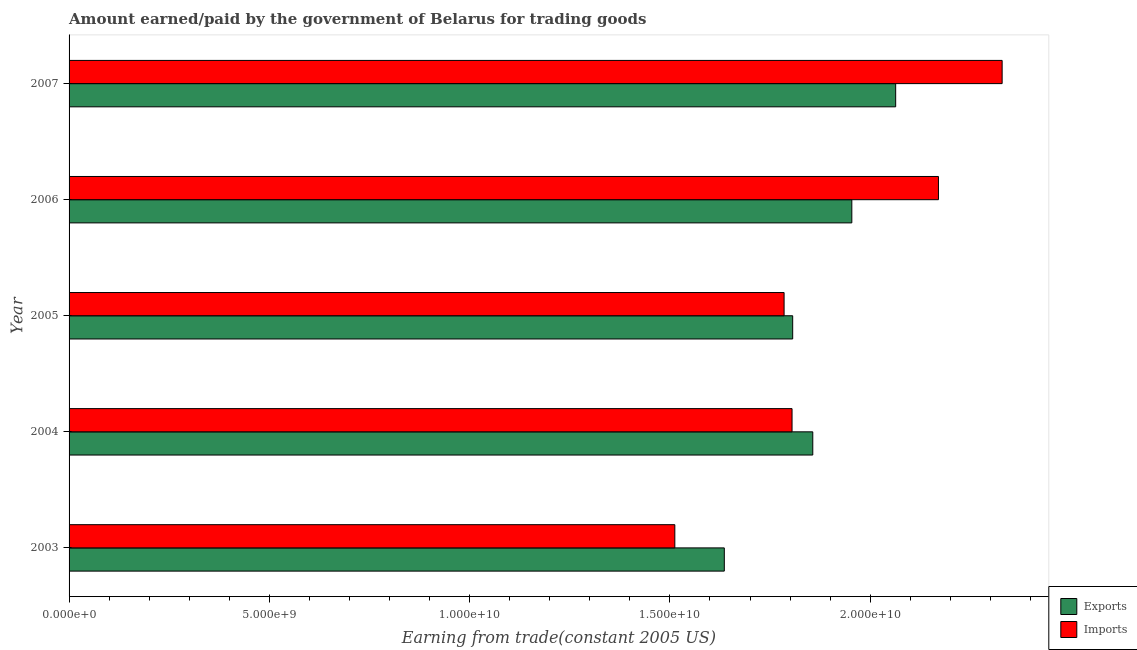How many different coloured bars are there?
Ensure brevity in your answer.  2. Are the number of bars per tick equal to the number of legend labels?
Give a very brief answer. Yes. How many bars are there on the 1st tick from the bottom?
Make the answer very short. 2. In how many cases, is the number of bars for a given year not equal to the number of legend labels?
Provide a short and direct response. 0. What is the amount paid for imports in 2004?
Keep it short and to the point. 1.80e+1. Across all years, what is the maximum amount paid for imports?
Offer a terse response. 2.33e+1. Across all years, what is the minimum amount earned from exports?
Your answer should be very brief. 1.64e+1. In which year was the amount paid for imports maximum?
Provide a short and direct response. 2007. In which year was the amount paid for imports minimum?
Your answer should be compact. 2003. What is the total amount earned from exports in the graph?
Your answer should be compact. 9.32e+1. What is the difference between the amount earned from exports in 2003 and that in 2005?
Keep it short and to the point. -1.71e+09. What is the difference between the amount paid for imports in 2007 and the amount earned from exports in 2005?
Keep it short and to the point. 5.23e+09. What is the average amount paid for imports per year?
Your answer should be very brief. 1.92e+1. In the year 2005, what is the difference between the amount earned from exports and amount paid for imports?
Provide a succinct answer. 2.15e+08. What is the ratio of the amount paid for imports in 2005 to that in 2006?
Ensure brevity in your answer.  0.82. Is the amount paid for imports in 2003 less than that in 2006?
Offer a very short reply. Yes. What is the difference between the highest and the second highest amount paid for imports?
Provide a short and direct response. 1.59e+09. What is the difference between the highest and the lowest amount earned from exports?
Offer a terse response. 4.28e+09. In how many years, is the amount paid for imports greater than the average amount paid for imports taken over all years?
Offer a very short reply. 2. Is the sum of the amount earned from exports in 2005 and 2006 greater than the maximum amount paid for imports across all years?
Keep it short and to the point. Yes. What does the 1st bar from the top in 2003 represents?
Your answer should be very brief. Imports. What does the 2nd bar from the bottom in 2003 represents?
Make the answer very short. Imports. Are all the bars in the graph horizontal?
Make the answer very short. Yes. Does the graph contain any zero values?
Your answer should be compact. No. Where does the legend appear in the graph?
Your response must be concise. Bottom right. What is the title of the graph?
Your answer should be very brief. Amount earned/paid by the government of Belarus for trading goods. What is the label or title of the X-axis?
Your response must be concise. Earning from trade(constant 2005 US). What is the label or title of the Y-axis?
Your response must be concise. Year. What is the Earning from trade(constant 2005 US) of Exports in 2003?
Make the answer very short. 1.64e+1. What is the Earning from trade(constant 2005 US) in Imports in 2003?
Provide a succinct answer. 1.51e+1. What is the Earning from trade(constant 2005 US) in Exports in 2004?
Offer a very short reply. 1.86e+1. What is the Earning from trade(constant 2005 US) in Imports in 2004?
Ensure brevity in your answer.  1.80e+1. What is the Earning from trade(constant 2005 US) in Exports in 2005?
Provide a short and direct response. 1.81e+1. What is the Earning from trade(constant 2005 US) of Imports in 2005?
Give a very brief answer. 1.79e+1. What is the Earning from trade(constant 2005 US) of Exports in 2006?
Give a very brief answer. 1.95e+1. What is the Earning from trade(constant 2005 US) in Imports in 2006?
Offer a very short reply. 2.17e+1. What is the Earning from trade(constant 2005 US) in Exports in 2007?
Offer a terse response. 2.06e+1. What is the Earning from trade(constant 2005 US) in Imports in 2007?
Offer a terse response. 2.33e+1. Across all years, what is the maximum Earning from trade(constant 2005 US) in Exports?
Keep it short and to the point. 2.06e+1. Across all years, what is the maximum Earning from trade(constant 2005 US) in Imports?
Your response must be concise. 2.33e+1. Across all years, what is the minimum Earning from trade(constant 2005 US) in Exports?
Your answer should be very brief. 1.64e+1. Across all years, what is the minimum Earning from trade(constant 2005 US) in Imports?
Give a very brief answer. 1.51e+1. What is the total Earning from trade(constant 2005 US) in Exports in the graph?
Provide a succinct answer. 9.32e+1. What is the total Earning from trade(constant 2005 US) in Imports in the graph?
Keep it short and to the point. 9.60e+1. What is the difference between the Earning from trade(constant 2005 US) of Exports in 2003 and that in 2004?
Offer a terse response. -2.21e+09. What is the difference between the Earning from trade(constant 2005 US) in Imports in 2003 and that in 2004?
Your response must be concise. -2.93e+09. What is the difference between the Earning from trade(constant 2005 US) in Exports in 2003 and that in 2005?
Offer a very short reply. -1.71e+09. What is the difference between the Earning from trade(constant 2005 US) in Imports in 2003 and that in 2005?
Your answer should be very brief. -2.73e+09. What is the difference between the Earning from trade(constant 2005 US) in Exports in 2003 and that in 2006?
Make the answer very short. -3.18e+09. What is the difference between the Earning from trade(constant 2005 US) of Imports in 2003 and that in 2006?
Your response must be concise. -6.58e+09. What is the difference between the Earning from trade(constant 2005 US) in Exports in 2003 and that in 2007?
Ensure brevity in your answer.  -4.28e+09. What is the difference between the Earning from trade(constant 2005 US) in Imports in 2003 and that in 2007?
Offer a terse response. -8.17e+09. What is the difference between the Earning from trade(constant 2005 US) of Exports in 2004 and that in 2005?
Provide a succinct answer. 5.01e+08. What is the difference between the Earning from trade(constant 2005 US) of Imports in 2004 and that in 2005?
Make the answer very short. 1.99e+08. What is the difference between the Earning from trade(constant 2005 US) in Exports in 2004 and that in 2006?
Make the answer very short. -9.75e+08. What is the difference between the Earning from trade(constant 2005 US) in Imports in 2004 and that in 2006?
Make the answer very short. -3.65e+09. What is the difference between the Earning from trade(constant 2005 US) of Exports in 2004 and that in 2007?
Provide a succinct answer. -2.07e+09. What is the difference between the Earning from trade(constant 2005 US) of Imports in 2004 and that in 2007?
Provide a short and direct response. -5.24e+09. What is the difference between the Earning from trade(constant 2005 US) of Exports in 2005 and that in 2006?
Provide a succinct answer. -1.48e+09. What is the difference between the Earning from trade(constant 2005 US) in Imports in 2005 and that in 2006?
Give a very brief answer. -3.85e+09. What is the difference between the Earning from trade(constant 2005 US) of Exports in 2005 and that in 2007?
Your response must be concise. -2.57e+09. What is the difference between the Earning from trade(constant 2005 US) in Imports in 2005 and that in 2007?
Offer a terse response. -5.44e+09. What is the difference between the Earning from trade(constant 2005 US) in Exports in 2006 and that in 2007?
Provide a short and direct response. -1.09e+09. What is the difference between the Earning from trade(constant 2005 US) of Imports in 2006 and that in 2007?
Your response must be concise. -1.59e+09. What is the difference between the Earning from trade(constant 2005 US) of Exports in 2003 and the Earning from trade(constant 2005 US) of Imports in 2004?
Provide a succinct answer. -1.69e+09. What is the difference between the Earning from trade(constant 2005 US) in Exports in 2003 and the Earning from trade(constant 2005 US) in Imports in 2005?
Keep it short and to the point. -1.49e+09. What is the difference between the Earning from trade(constant 2005 US) in Exports in 2003 and the Earning from trade(constant 2005 US) in Imports in 2006?
Your answer should be compact. -5.35e+09. What is the difference between the Earning from trade(constant 2005 US) in Exports in 2003 and the Earning from trade(constant 2005 US) in Imports in 2007?
Ensure brevity in your answer.  -6.94e+09. What is the difference between the Earning from trade(constant 2005 US) in Exports in 2004 and the Earning from trade(constant 2005 US) in Imports in 2005?
Your response must be concise. 7.16e+08. What is the difference between the Earning from trade(constant 2005 US) in Exports in 2004 and the Earning from trade(constant 2005 US) in Imports in 2006?
Your response must be concise. -3.14e+09. What is the difference between the Earning from trade(constant 2005 US) of Exports in 2004 and the Earning from trade(constant 2005 US) of Imports in 2007?
Offer a very short reply. -4.73e+09. What is the difference between the Earning from trade(constant 2005 US) of Exports in 2005 and the Earning from trade(constant 2005 US) of Imports in 2006?
Your answer should be very brief. -3.64e+09. What is the difference between the Earning from trade(constant 2005 US) of Exports in 2005 and the Earning from trade(constant 2005 US) of Imports in 2007?
Your response must be concise. -5.23e+09. What is the difference between the Earning from trade(constant 2005 US) of Exports in 2006 and the Earning from trade(constant 2005 US) of Imports in 2007?
Provide a short and direct response. -3.75e+09. What is the average Earning from trade(constant 2005 US) in Exports per year?
Make the answer very short. 1.86e+1. What is the average Earning from trade(constant 2005 US) in Imports per year?
Offer a terse response. 1.92e+1. In the year 2003, what is the difference between the Earning from trade(constant 2005 US) of Exports and Earning from trade(constant 2005 US) of Imports?
Your response must be concise. 1.24e+09. In the year 2004, what is the difference between the Earning from trade(constant 2005 US) of Exports and Earning from trade(constant 2005 US) of Imports?
Your response must be concise. 5.18e+08. In the year 2005, what is the difference between the Earning from trade(constant 2005 US) in Exports and Earning from trade(constant 2005 US) in Imports?
Ensure brevity in your answer.  2.15e+08. In the year 2006, what is the difference between the Earning from trade(constant 2005 US) in Exports and Earning from trade(constant 2005 US) in Imports?
Provide a succinct answer. -2.16e+09. In the year 2007, what is the difference between the Earning from trade(constant 2005 US) in Exports and Earning from trade(constant 2005 US) in Imports?
Your answer should be compact. -2.66e+09. What is the ratio of the Earning from trade(constant 2005 US) in Exports in 2003 to that in 2004?
Provide a succinct answer. 0.88. What is the ratio of the Earning from trade(constant 2005 US) in Imports in 2003 to that in 2004?
Ensure brevity in your answer.  0.84. What is the ratio of the Earning from trade(constant 2005 US) in Exports in 2003 to that in 2005?
Your answer should be very brief. 0.91. What is the ratio of the Earning from trade(constant 2005 US) in Imports in 2003 to that in 2005?
Your response must be concise. 0.85. What is the ratio of the Earning from trade(constant 2005 US) of Exports in 2003 to that in 2006?
Offer a terse response. 0.84. What is the ratio of the Earning from trade(constant 2005 US) in Imports in 2003 to that in 2006?
Your response must be concise. 0.7. What is the ratio of the Earning from trade(constant 2005 US) in Exports in 2003 to that in 2007?
Make the answer very short. 0.79. What is the ratio of the Earning from trade(constant 2005 US) in Imports in 2003 to that in 2007?
Provide a succinct answer. 0.65. What is the ratio of the Earning from trade(constant 2005 US) of Exports in 2004 to that in 2005?
Your answer should be compact. 1.03. What is the ratio of the Earning from trade(constant 2005 US) of Imports in 2004 to that in 2005?
Offer a very short reply. 1.01. What is the ratio of the Earning from trade(constant 2005 US) in Exports in 2004 to that in 2006?
Give a very brief answer. 0.95. What is the ratio of the Earning from trade(constant 2005 US) in Imports in 2004 to that in 2006?
Offer a terse response. 0.83. What is the ratio of the Earning from trade(constant 2005 US) in Exports in 2004 to that in 2007?
Keep it short and to the point. 0.9. What is the ratio of the Earning from trade(constant 2005 US) of Imports in 2004 to that in 2007?
Your answer should be compact. 0.77. What is the ratio of the Earning from trade(constant 2005 US) in Exports in 2005 to that in 2006?
Offer a terse response. 0.92. What is the ratio of the Earning from trade(constant 2005 US) of Imports in 2005 to that in 2006?
Ensure brevity in your answer.  0.82. What is the ratio of the Earning from trade(constant 2005 US) in Exports in 2005 to that in 2007?
Provide a short and direct response. 0.88. What is the ratio of the Earning from trade(constant 2005 US) of Imports in 2005 to that in 2007?
Provide a succinct answer. 0.77. What is the ratio of the Earning from trade(constant 2005 US) of Exports in 2006 to that in 2007?
Give a very brief answer. 0.95. What is the ratio of the Earning from trade(constant 2005 US) in Imports in 2006 to that in 2007?
Make the answer very short. 0.93. What is the difference between the highest and the second highest Earning from trade(constant 2005 US) in Exports?
Ensure brevity in your answer.  1.09e+09. What is the difference between the highest and the second highest Earning from trade(constant 2005 US) in Imports?
Keep it short and to the point. 1.59e+09. What is the difference between the highest and the lowest Earning from trade(constant 2005 US) of Exports?
Make the answer very short. 4.28e+09. What is the difference between the highest and the lowest Earning from trade(constant 2005 US) in Imports?
Ensure brevity in your answer.  8.17e+09. 